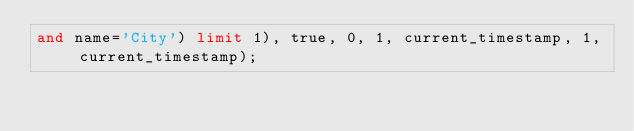Convert code to text. <code><loc_0><loc_0><loc_500><loc_500><_SQL_>and name='City') limit 1), true, 0, 1, current_timestamp, 1, current_timestamp);</code> 